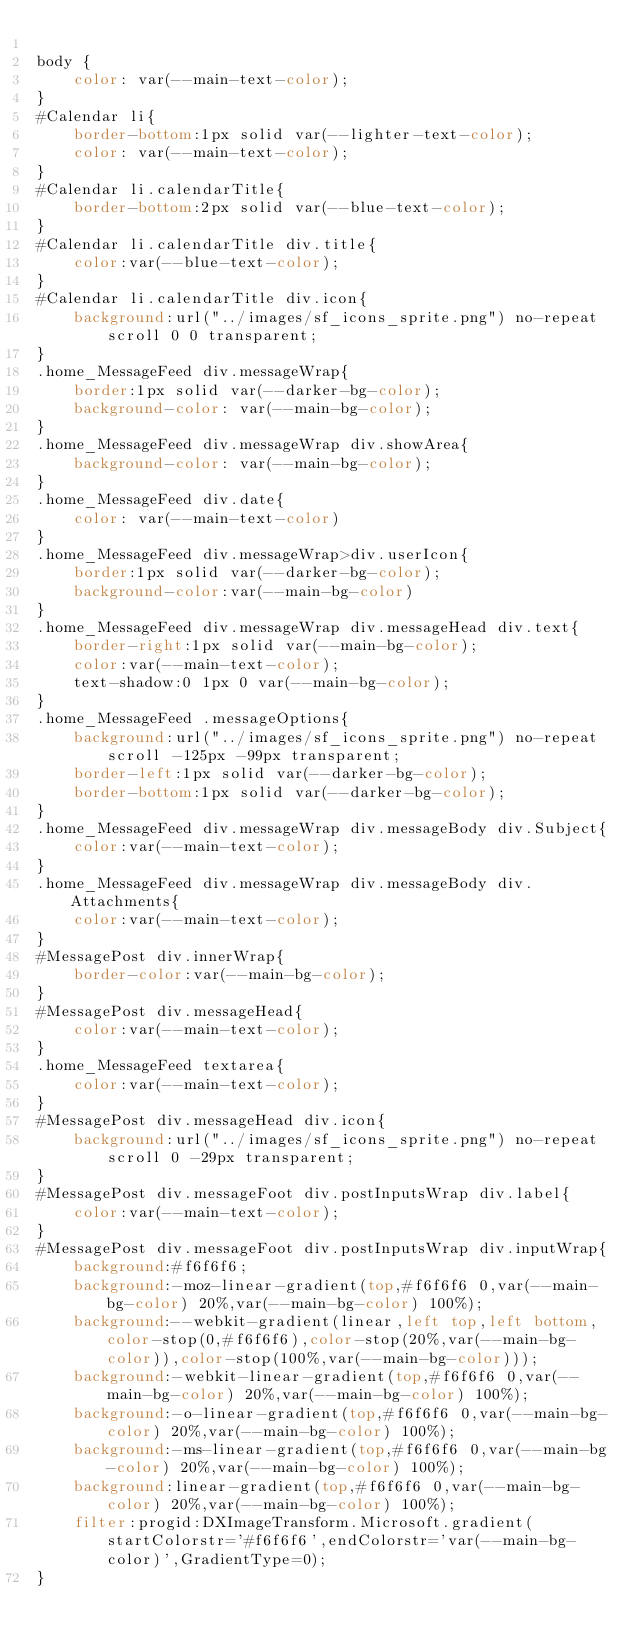Convert code to text. <code><loc_0><loc_0><loc_500><loc_500><_CSS_>
body {
    color: var(--main-text-color);
}
#Calendar li{
    border-bottom:1px solid var(--lighter-text-color);
    color: var(--main-text-color);
}
#Calendar li.calendarTitle{
    border-bottom:2px solid var(--blue-text-color);
}
#Calendar li.calendarTitle div.title{
    color:var(--blue-text-color);
}
#Calendar li.calendarTitle div.icon{
    background:url("../images/sf_icons_sprite.png") no-repeat scroll 0 0 transparent;
}
.home_MessageFeed div.messageWrap{
    border:1px solid var(--darker-bg-color);
    background-color: var(--main-bg-color);
}
.home_MessageFeed div.messageWrap div.showArea{
    background-color: var(--main-bg-color);
}
.home_MessageFeed div.date{
    color: var(--main-text-color)
}
.home_MessageFeed div.messageWrap>div.userIcon{
    border:1px solid var(--darker-bg-color);
    background-color:var(--main-bg-color)
}
.home_MessageFeed div.messageWrap div.messageHead div.text{
    border-right:1px solid var(--main-bg-color);
    color:var(--main-text-color);
    text-shadow:0 1px 0 var(--main-bg-color);
}
.home_MessageFeed .messageOptions{
    background:url("../images/sf_icons_sprite.png") no-repeat scroll -125px -99px transparent;
    border-left:1px solid var(--darker-bg-color);
    border-bottom:1px solid var(--darker-bg-color);
}
.home_MessageFeed div.messageWrap div.messageBody div.Subject{
    color:var(--main-text-color);
}
.home_MessageFeed div.messageWrap div.messageBody div.Attachments{
    color:var(--main-text-color);
}
#MessagePost div.innerWrap{
    border-color:var(--main-bg-color);
}
#MessagePost div.messageHead{
    color:var(--main-text-color);
}
.home_MessageFeed textarea{
    color:var(--main-text-color);
}
#MessagePost div.messageHead div.icon{
    background:url("../images/sf_icons_sprite.png") no-repeat scroll 0 -29px transparent;
}
#MessagePost div.messageFoot div.postInputsWrap div.label{
    color:var(--main-text-color);
}
#MessagePost div.messageFoot div.postInputsWrap div.inputWrap{
    background:#f6f6f6;
    background:-moz-linear-gradient(top,#f6f6f6 0,var(--main-bg-color) 20%,var(--main-bg-color) 100%);
    background:--webkit-gradient(linear,left top,left bottom,color-stop(0,#f6f6f6),color-stop(20%,var(--main-bg-color)),color-stop(100%,var(--main-bg-color)));
    background:-webkit-linear-gradient(top,#f6f6f6 0,var(--main-bg-color) 20%,var(--main-bg-color) 100%);
    background:-o-linear-gradient(top,#f6f6f6 0,var(--main-bg-color) 20%,var(--main-bg-color) 100%);
    background:-ms-linear-gradient(top,#f6f6f6 0,var(--main-bg-color) 20%,var(--main-bg-color) 100%);
    background:linear-gradient(top,#f6f6f6 0,var(--main-bg-color) 20%,var(--main-bg-color) 100%);
    filter:progid:DXImageTransform.Microsoft.gradient(startColorstr='#f6f6f6',endColorstr='var(--main-bg-color)',GradientType=0);
}</code> 